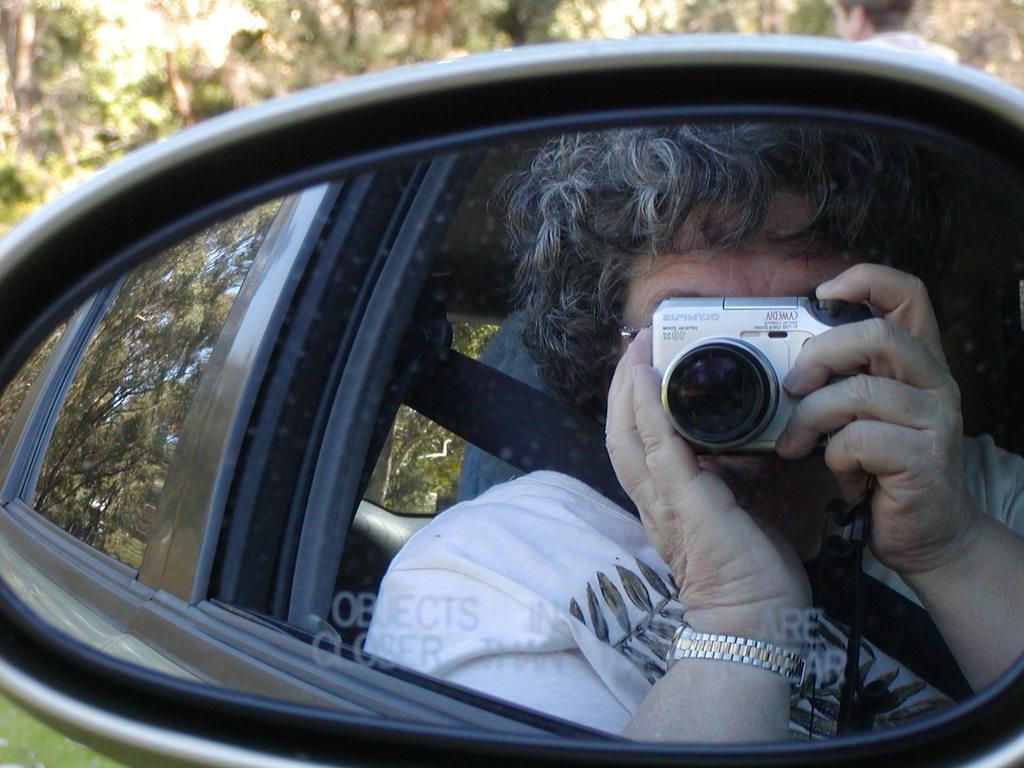Can you describe this image briefly? This is car, a person is holding camera, these are trees. 